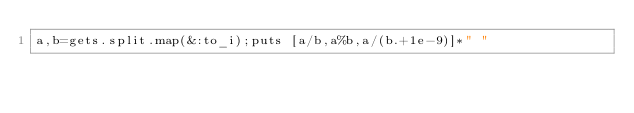<code> <loc_0><loc_0><loc_500><loc_500><_Ruby_>a,b=gets.split.map(&:to_i);puts [a/b,a%b,a/(b.+1e-9)]*" "</code> 